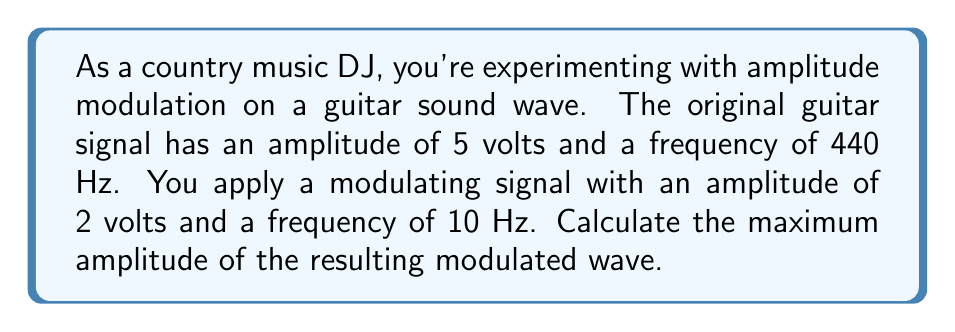Teach me how to tackle this problem. To solve this problem, we'll use the formula for amplitude modulation:

1) The amplitude-modulated signal is given by:
   $$s(t) = A_c[1 + m\cos(2\pi f_m t)]\cos(2\pi f_c t)$$

   Where:
   $A_c$ = carrier (original) signal amplitude
   $m$ = modulation index
   $f_m$ = modulating frequency
   $f_c$ = carrier frequency

2) First, we need to calculate the modulation index $m$:
   $$m = \frac{A_m}{A_c}$$
   Where $A_m$ is the amplitude of the modulating signal.

3) Substituting the values:
   $$m = \frac{2}{5} = 0.4$$

4) The maximum amplitude of the modulated wave occurs when both cosine terms are at their maximum (1). So, we can simplify the equation to:
   $$A_{max} = A_c(1 + m)$$

5) Substituting the values:
   $$A_{max} = 5(1 + 0.4) = 5(1.4) = 7$$

Therefore, the maximum amplitude of the resulting modulated wave is 7 volts.
Answer: 7 volts 